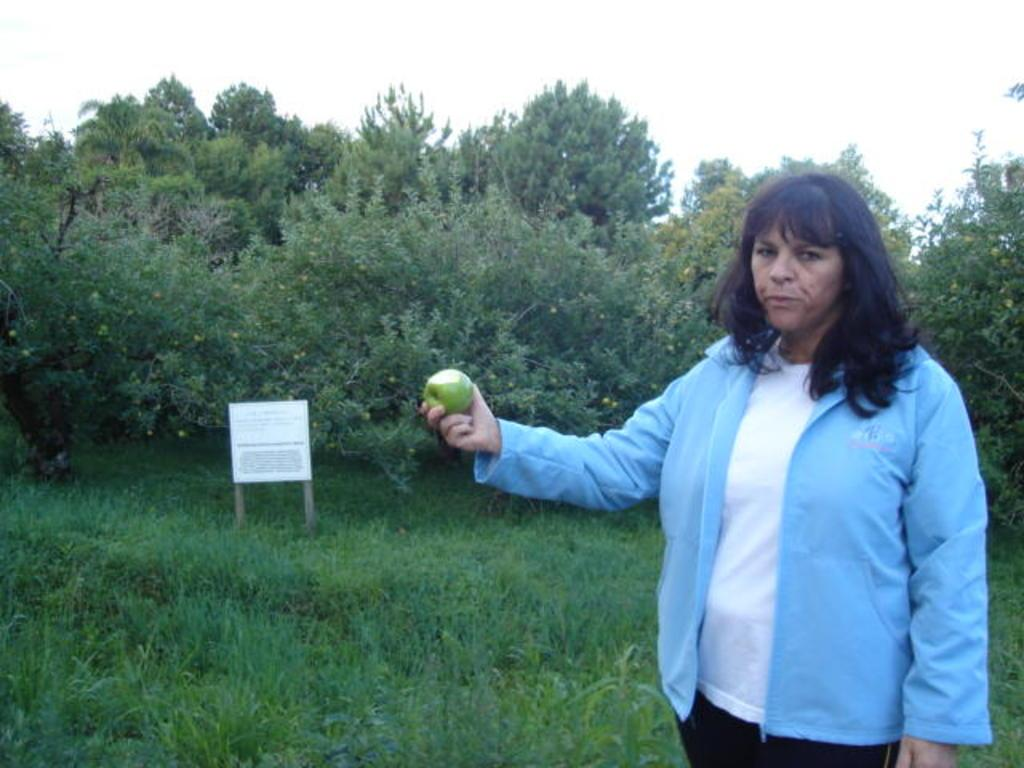What is the person in the image doing? The person is standing in the image and holding a fruit. What else can be seen in the image besides the person? There is a board with text in the image. What is visible in the background of the image? Grass, trees, and the sky are visible in the background of the image. How many chickens are sitting on the curve in the image? There are no chickens or curves present in the image. 